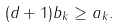<formula> <loc_0><loc_0><loc_500><loc_500>( d + 1 ) b _ { k } \geq a _ { k } .</formula> 